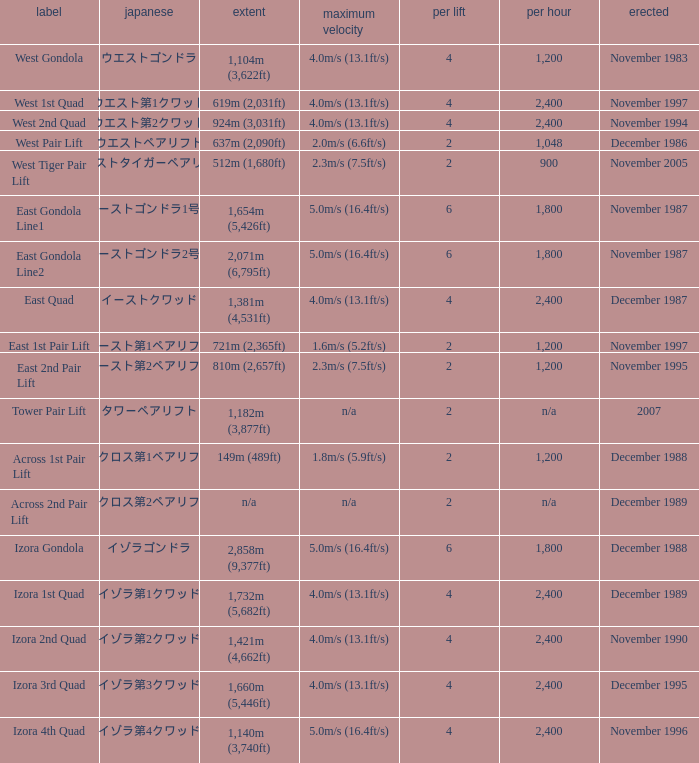How heavy is the  maximum 6.0. 